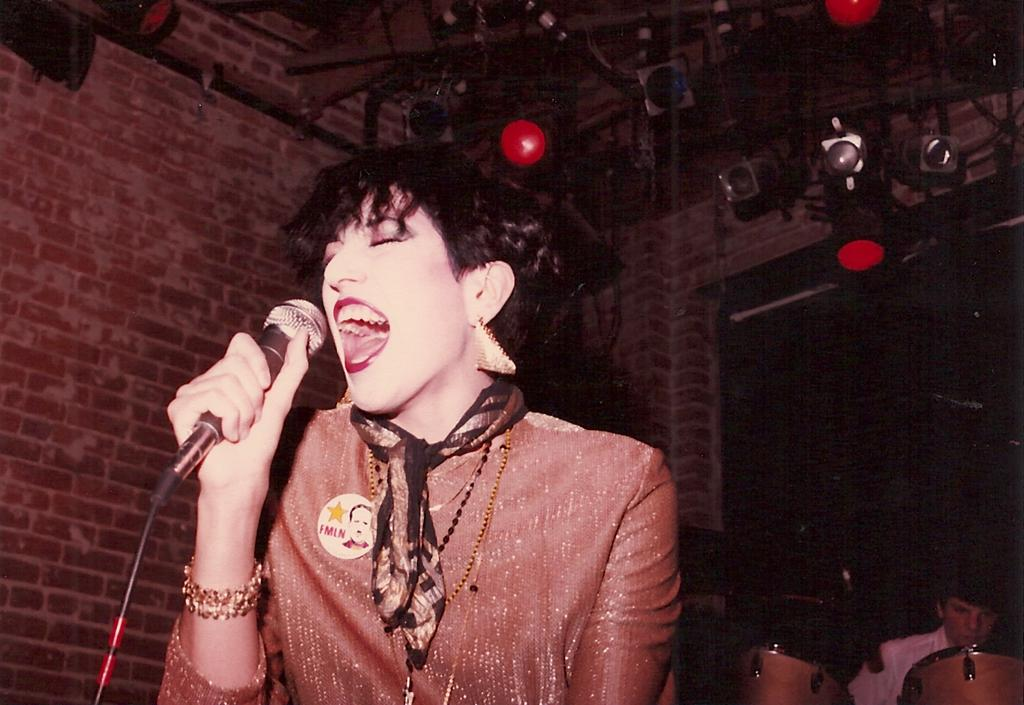What is the lady doing on the stage in the image? The lady is standing and singing on the stage in the image. What is the man doing in the image? The man is playing musical instruments in the image. Can you describe the lighting in the image? There are lights on the roof in the image. Where is the quince located in the image? There is no quince present in the image. What type of nest can be seen in the image? There is no nest present in the image. 